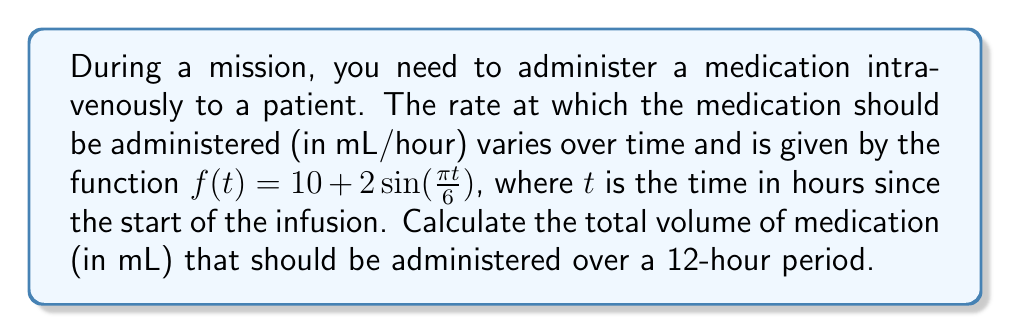What is the answer to this math problem? To solve this problem, we need to use integration to find the area under the curve of the rate function over the given time period. This area represents the total volume of medication administered.

1) The function representing the rate of medication administration is:
   $f(t) = 10 + 2\sin(\frac{\pi t}{6})$ mL/hour

2) We need to integrate this function from t = 0 to t = 12 hours:
   $V = \int_0^{12} (10 + 2\sin(\frac{\pi t}{6})) dt$

3) Let's break this integral into two parts:
   $V = \int_0^{12} 10 dt + \int_0^{12} 2\sin(\frac{\pi t}{6}) dt$

4) The first part is straightforward:
   $\int_0^{12} 10 dt = 10t |_0^{12} = 120$

5) For the second part, we use the substitution method:
   Let $u = \frac{\pi t}{6}$, then $du = \frac{\pi}{6} dt$ or $dt = \frac{6}{\pi} du$
   When $t = 0$, $u = 0$; when $t = 12$, $u = 2\pi$

   $\int_0^{12} 2\sin(\frac{\pi t}{6}) dt = 2 \cdot \frac{6}{\pi} \int_0^{2\pi} \sin(u) du$
                                         $= \frac{12}{\pi} [-\cos(u)]_0^{2\pi}$
                                         $= \frac{12}{\pi} [-\cos(2\pi) + \cos(0)]$
                                         $= \frac{12}{\pi} [-(1) + 1] = 0$

6) Adding the results from steps 4 and 5:
   $V = 120 + 0 = 120$ mL

Therefore, the total volume of medication to be administered over 12 hours is 120 mL.
Answer: 120 mL 